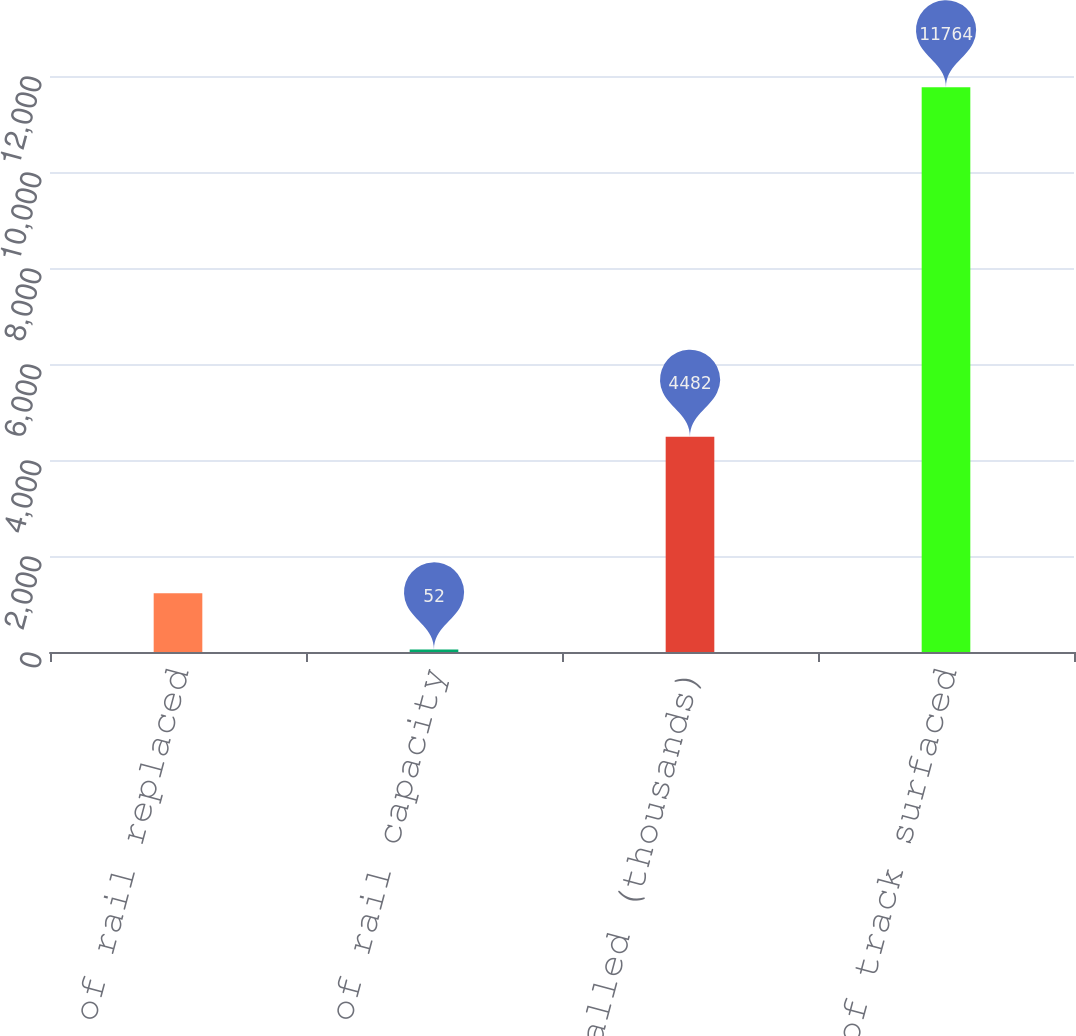<chart> <loc_0><loc_0><loc_500><loc_500><bar_chart><fcel>Track miles of rail replaced<fcel>Track miles of rail capacity<fcel>New ties installed (thousands)<fcel>Miles of track surfaced<nl><fcel>1223.2<fcel>52<fcel>4482<fcel>11764<nl></chart> 